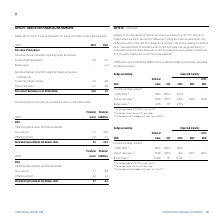According to Torm's financial document, What information is provided in Note 21? further information on fair value hierarchies.. The document states: "lease refer to note 21 “Financial Instruments” for further information on fair value hierarchies...." Also, What are the types of derivative financial instruments regarding freight and bunkers? The document shows two values: Forward freight agreements and Bunker swaps. From the document: "Forward freight agreements -0.3 0.5 Bunker swaps - -1.2..." Also, What are the types of derivative financial instruments regarding interest and currency exchange rate? The document shows two values: Forward exchange contracts and Interest rate swaps. From the document: "Forward exchange contracts -0.4 -1.8 Interest rate swaps -11.1 2.8..." Additionally, In which year was the amount of forward exchange contracts larger? According to the financial document, 2018. The relevant text states: "USDm 2019 2018..." Also, can you calculate: What was the change in interest rate swaps from 2018 to 2019? Based on the calculation: -11.1-2.8, the result is -13.9 (in millions). This is based on the information: "Interest rate swaps -11.1 2.8 Interest rate swaps -11.1 2.8..." The key data points involved are: 11.1, 2.8. Also, can you calculate: What was the percentage change in interest rate swaps from 2018 to 2019? To answer this question, I need to perform calculations using the financial data. The calculation is: (-11.1-2.8)/2.8, which equals -496.43 (percentage). This is based on the information: "Interest rate swaps -11.1 2.8 Interest rate swaps -11.1 2.8..." The key data points involved are: 11.1, 2.8. 